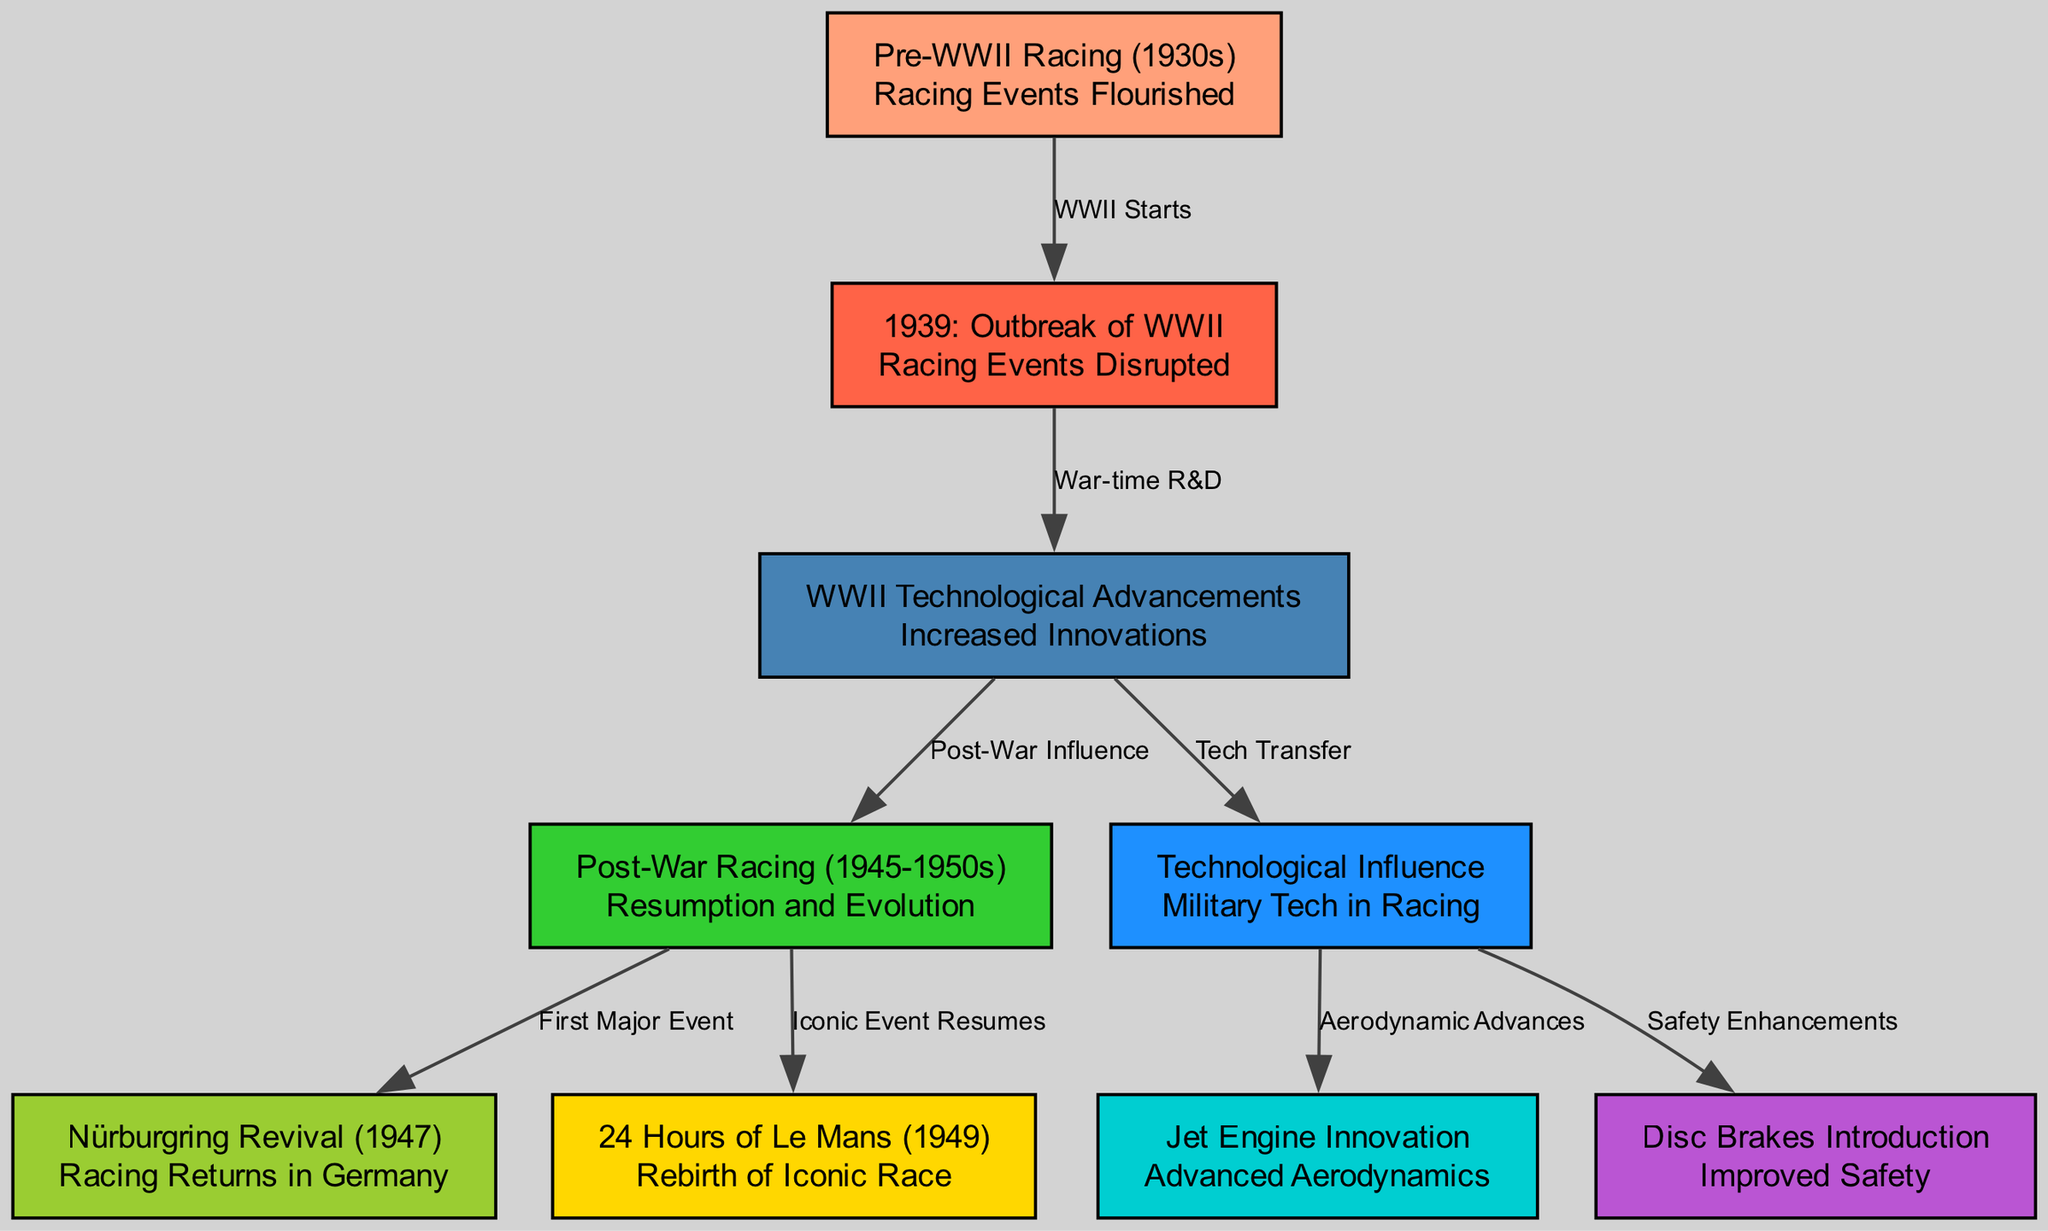What was the status of racing events in the 1930s? The node labeled "Pre-WWII Racing (1930s)" indicates that racing events flourished during this period, implying that many racing events took place before the war.
Answer: Racing Events Flourished Which event marked the disruption of racing in 1939? The transition from "Pre-WWII Racing (1930s)" to "1939: Outbreak of WWII" signifies that the outbreak of World War II disrupted racing events in that year.
Answer: Outbreak of WWII How many technological advancements are shown in the diagram? By counting the nodes related to technological advancements, including "WWII Technological Advancements," "Technological Influence," "Jet Engine Innovation," and "Disc Brakes Introduction," we find a total of four advancements depicted in the diagram.
Answer: 4 What major racing event resumed in 1949? The node labeled "24 Hours of Le Mans (1949)" specifically states it is the rebirth of this iconic race, indicating that this was a significant event in the post-war era.
Answer: 24 Hours of Le Mans What influence did World War II have on post-war racing? The arrow from "WWII Technological Advancements" to "Post-War Racing" indicates that the technological advancements gained during the war influenced the state of racing afterwards.
Answer: Post-War Influence What was the first major racing event after WWII? The directed edge from "Post_War_Racing" to "Nurburgring Revival (1947)" shows that the Nürburgring Revival in 1947 was the first major racing event to return post-war.
Answer: Nürburgring Revival How did military technology impact racing innovations? The relationship from "WWII Technological Advancements" to "Technological Influence" demonstrates that technological advances made during the war transferred to innovations within the racing domain.
Answer: Tech Transfer What safety feature was introduced as a result of wartime advancements? The edge leading from "Technological Influence" to "Disc Brakes Introduction" indicates that disc brakes were introduced as an important safety enhancement in racing, directly linked to wartime technological advancements.
Answer: Disc Brakes Introduction 